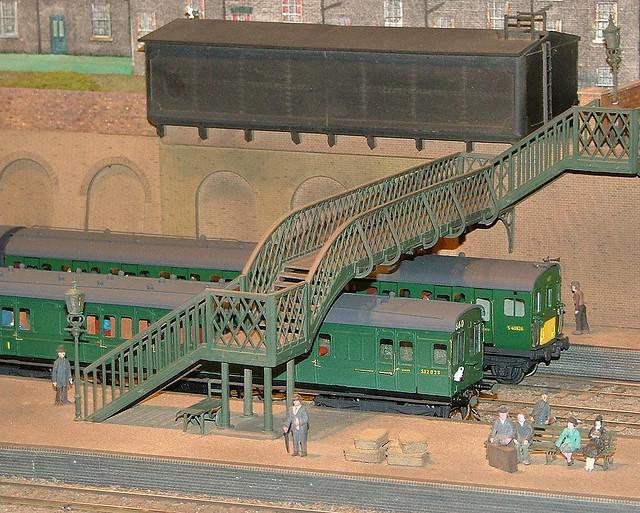What type of trains are shown here?

Choices:
A) miniature
B) electric
C) tram
D) diesel miniature 